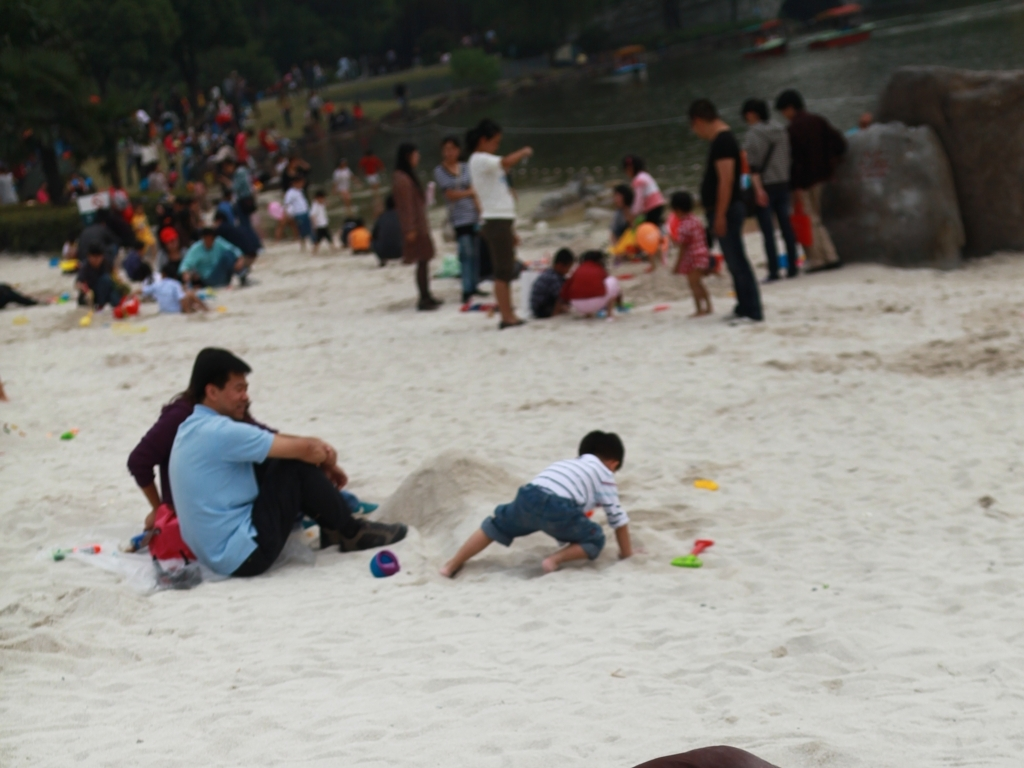Does the image seem to be taken during a special event? There's no clear indication of a special event in the image; it appears to be a regular day out for these individuals with no signs of decorations, special attire, or event-specific activities that would suggest a celebration or festival is taking place. 